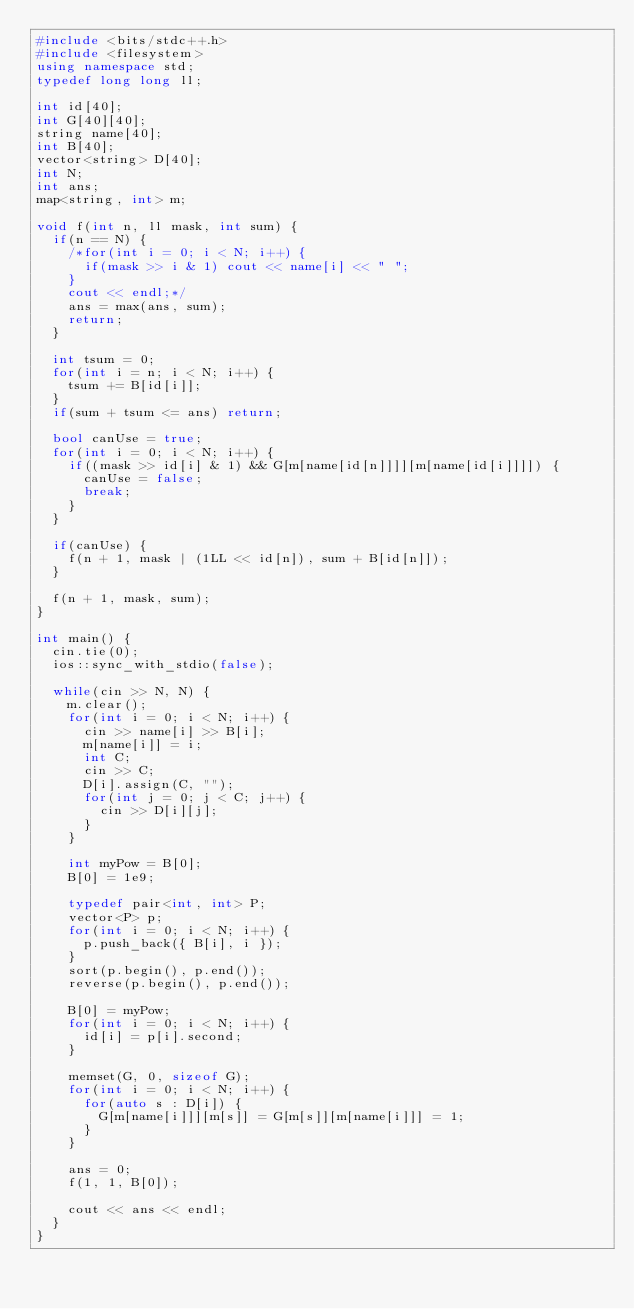<code> <loc_0><loc_0><loc_500><loc_500><_C++_>#include <bits/stdc++.h>
#include <filesystem>
using namespace std;
typedef long long ll;

int id[40];
int G[40][40];
string name[40];
int B[40];
vector<string> D[40];
int N;
int ans;
map<string, int> m;

void f(int n, ll mask, int sum) {
	if(n == N) {
		/*for(int i = 0; i < N; i++) {
			if(mask >> i & 1) cout << name[i] << " ";
		}
		cout << endl;*/
		ans = max(ans, sum);
		return;
	}

	int tsum = 0;
	for(int i = n; i < N; i++) {
		tsum += B[id[i]];
	}
	if(sum + tsum <= ans) return;

	bool canUse = true;
	for(int i = 0; i < N; i++) {
		if((mask >> id[i] & 1) && G[m[name[id[n]]]][m[name[id[i]]]]) {
			canUse = false;
			break;
		}
	}

	if(canUse) {
		f(n + 1, mask | (1LL << id[n]), sum + B[id[n]]);
	}

	f(n + 1, mask, sum);
}

int main() {
	cin.tie(0);
	ios::sync_with_stdio(false);

	while(cin >> N, N) {
		m.clear();
		for(int i = 0; i < N; i++) {
			cin >> name[i] >> B[i];
			m[name[i]] = i;
			int C;
			cin >> C;
			D[i].assign(C, "");
			for(int j = 0; j < C; j++) {
				cin >> D[i][j];
			}
		}

		int myPow = B[0];
		B[0] = 1e9;

		typedef pair<int, int> P;
		vector<P> p;
		for(int i = 0; i < N; i++) {
			p.push_back({ B[i], i });
		}
		sort(p.begin(), p.end());
		reverse(p.begin(), p.end());

		B[0] = myPow;
		for(int i = 0; i < N; i++) {
			id[i] = p[i].second;
		}

		memset(G, 0, sizeof G);
		for(int i = 0; i < N; i++) {
			for(auto s : D[i]) {
				G[m[name[i]]][m[s]] = G[m[s]][m[name[i]]] = 1;
			}
		}

		ans = 0;
		f(1, 1, B[0]);

		cout << ans << endl;
	}
}</code> 